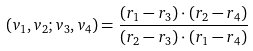<formula> <loc_0><loc_0><loc_500><loc_500>( v _ { 1 } , v _ { 2 } ; v _ { 3 } , v _ { 4 } ) = \frac { ( r _ { 1 } - r _ { 3 } ) \cdot ( r _ { 2 } - r _ { 4 } ) } { ( r _ { 2 } - r _ { 3 } ) \cdot ( r _ { 1 } - r _ { 4 } ) }</formula> 